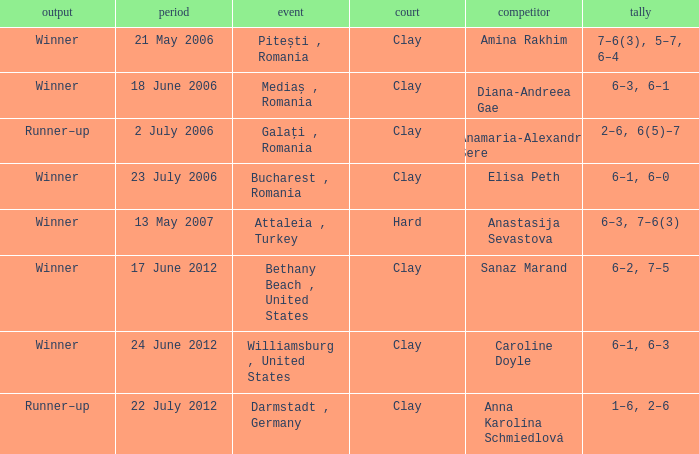What tournament was held on 21 May 2006? Pitești , Romania. 